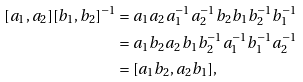Convert formula to latex. <formula><loc_0><loc_0><loc_500><loc_500>[ a _ { 1 } , a _ { 2 } ] [ b _ { 1 } , b _ { 2 } ] ^ { - 1 } & = a _ { 1 } a _ { 2 } a _ { 1 } ^ { - 1 } a _ { 2 } ^ { - 1 } b _ { 2 } b _ { 1 } b _ { 2 } ^ { - 1 } b _ { 1 } ^ { - 1 } \\ & = a _ { 1 } b _ { 2 } a _ { 2 } b _ { 1 } b _ { 2 } ^ { - 1 } a _ { 1 } ^ { - 1 } b _ { 1 } ^ { - 1 } a _ { 2 } ^ { - 1 } \\ & = [ a _ { 1 } b _ { 2 } , a _ { 2 } b _ { 1 } ] ,</formula> 